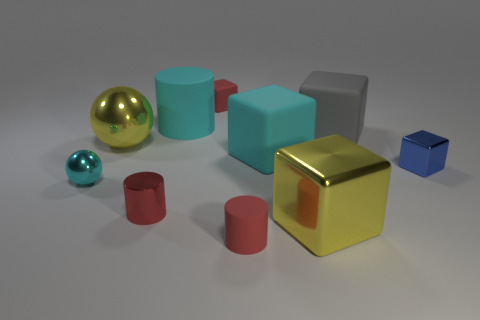There is a metal thing that is on the left side of the large yellow shiny ball; is it the same color as the tiny cylinder on the left side of the large cyan cylinder?
Your answer should be very brief. No. How many red metal cylinders are the same size as the blue cube?
Your response must be concise. 1. There is a cube in front of the shiny cylinder; is its size the same as the small shiny cylinder?
Provide a short and direct response. No. What shape is the small cyan metal object?
Give a very brief answer. Sphere. What size is the block that is the same color as the large shiny ball?
Your answer should be compact. Large. Is the red cylinder on the right side of the big matte cylinder made of the same material as the big yellow ball?
Make the answer very short. No. Is there a metal thing that has the same color as the big metal ball?
Offer a very short reply. Yes. There is a cyan thing behind the cyan cube; is it the same shape as the tiny metallic thing right of the large metal block?
Provide a short and direct response. No. Are there any big yellow things that have the same material as the large cylinder?
Ensure brevity in your answer.  No. How many purple things are large shiny cylinders or tiny rubber cylinders?
Offer a terse response. 0. 